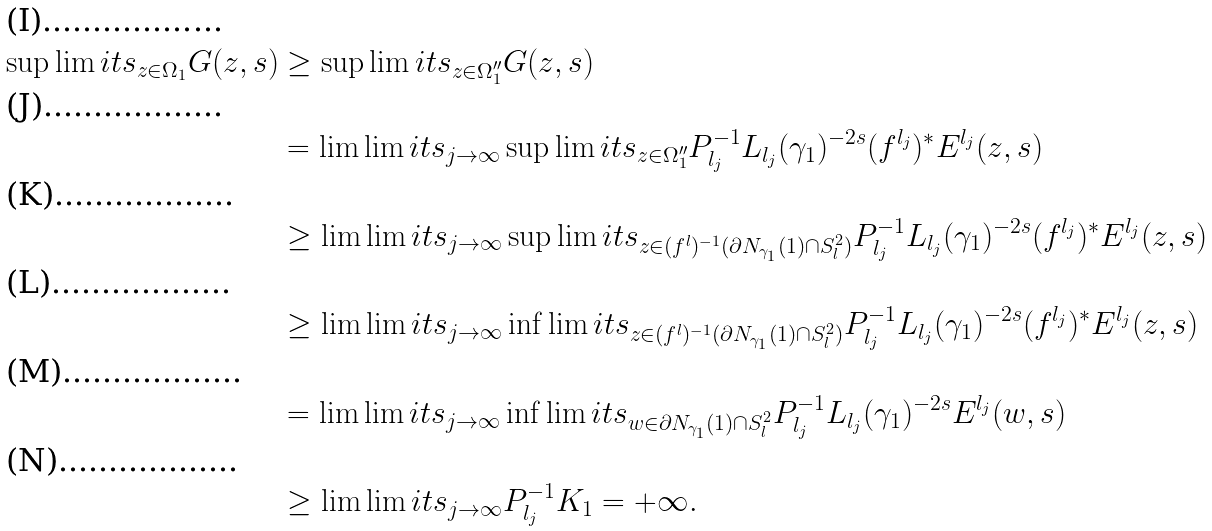<formula> <loc_0><loc_0><loc_500><loc_500>\sup \lim i t s _ { z \in \Omega _ { 1 } } G ( z , s ) & \geq \sup \lim i t s _ { z \in \Omega _ { 1 } ^ { \prime \prime } } G ( z , s ) \\ & = \lim \lim i t s _ { j \rightarrow \infty } \sup \lim i t s _ { z \in \Omega _ { 1 } ^ { \prime \prime } } P _ { l _ { j } } ^ { - 1 } L _ { l _ { j } } ( \gamma _ { 1 } ) ^ { - 2 s } ( f ^ { l _ { j } } ) ^ { * } E ^ { l _ { j } } ( z , s ) \\ & \geq \lim \lim i t s _ { j \rightarrow \infty } \sup \lim i t s _ { z \in ( f ^ { l } ) ^ { - 1 } ( \partial N _ { \gamma _ { 1 } } ( 1 ) \cap S _ { l } ^ { 2 } ) } P _ { l _ { j } } ^ { - 1 } L _ { l _ { j } } ( \gamma _ { 1 } ) ^ { - 2 s } ( f ^ { l _ { j } } ) ^ { * } E ^ { l _ { j } } ( z , s ) \\ & \geq \lim \lim i t s _ { j \rightarrow \infty } \inf \lim i t s _ { z \in ( f ^ { l } ) ^ { - 1 } ( \partial N _ { \gamma _ { 1 } } ( 1 ) \cap S _ { l } ^ { 2 } ) } P _ { l _ { j } } ^ { - 1 } L _ { l _ { j } } ( \gamma _ { 1 } ) ^ { - 2 s } ( f ^ { l _ { j } } ) ^ { * } E ^ { l _ { j } } ( z , s ) \\ & = \lim \lim i t s _ { j \rightarrow \infty } \inf \lim i t s _ { w \in \partial N _ { \gamma _ { 1 } } ( 1 ) \cap S _ { l } ^ { 2 } } P _ { l _ { j } } ^ { - 1 } L _ { l _ { j } } ( \gamma _ { 1 } ) ^ { - 2 s } E ^ { l _ { j } } ( w , s ) \\ & \geq \lim \lim i t s _ { j \rightarrow \infty } P _ { l _ { j } } ^ { - 1 } K _ { 1 } = + \infty .</formula> 